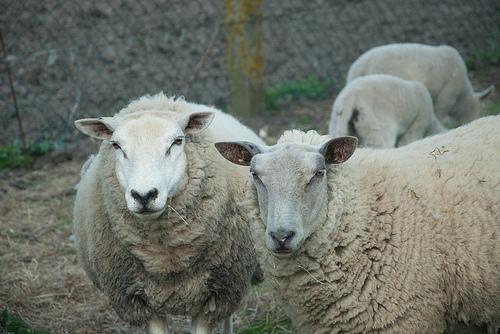How many sheep are there?
Give a very brief answer. 4. 